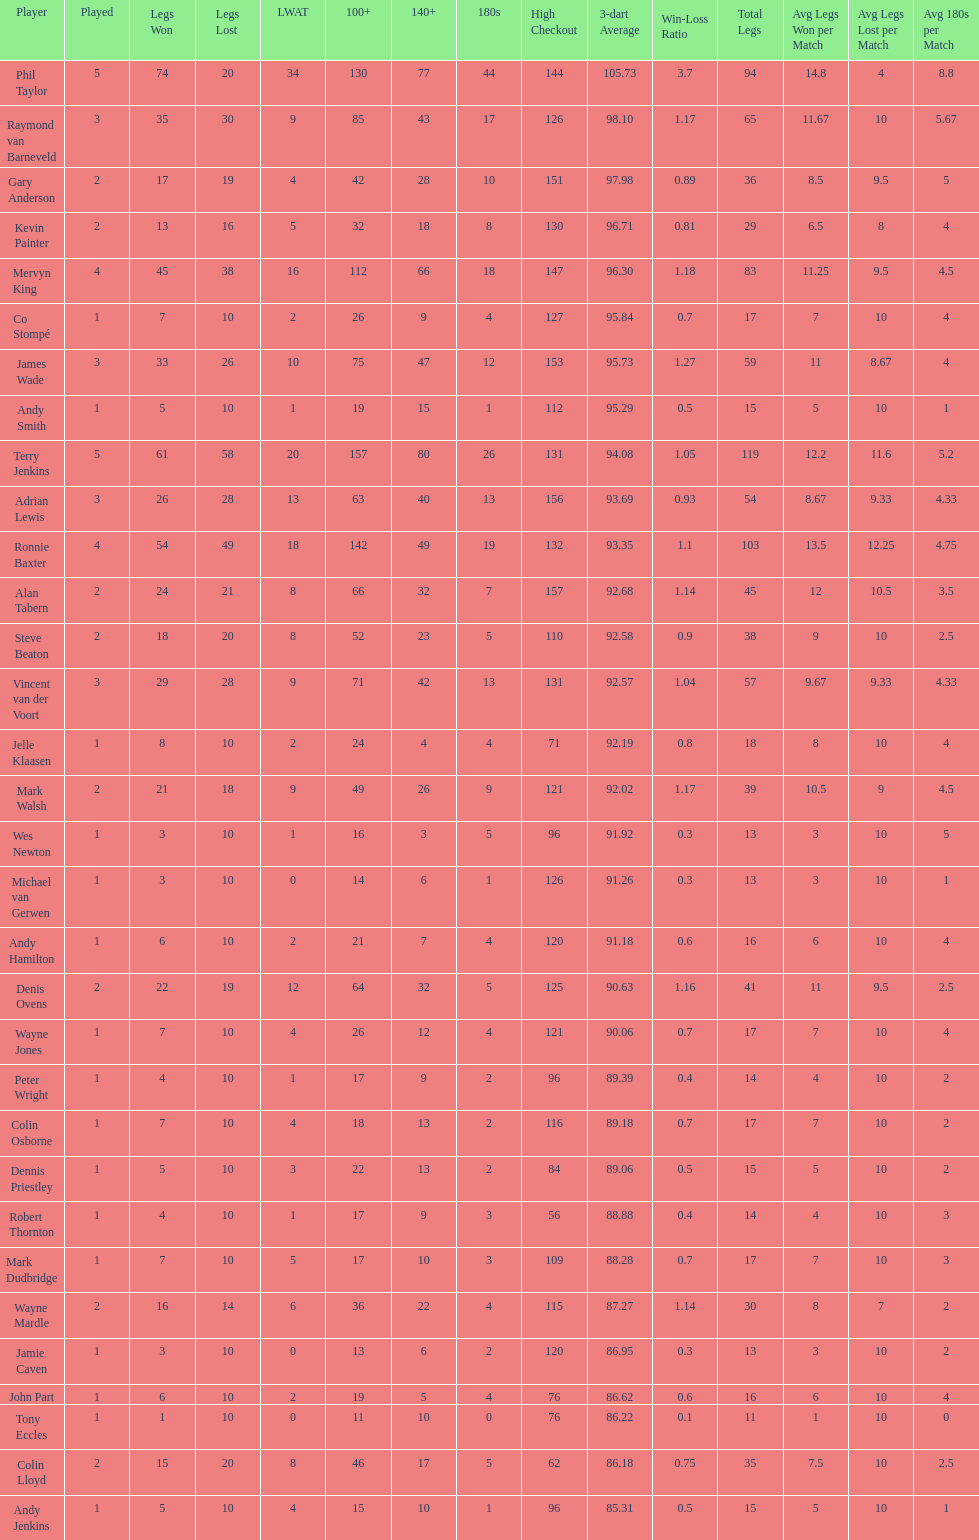Was andy smith or kevin painter's 3-dart average 96.71? Kevin Painter. 